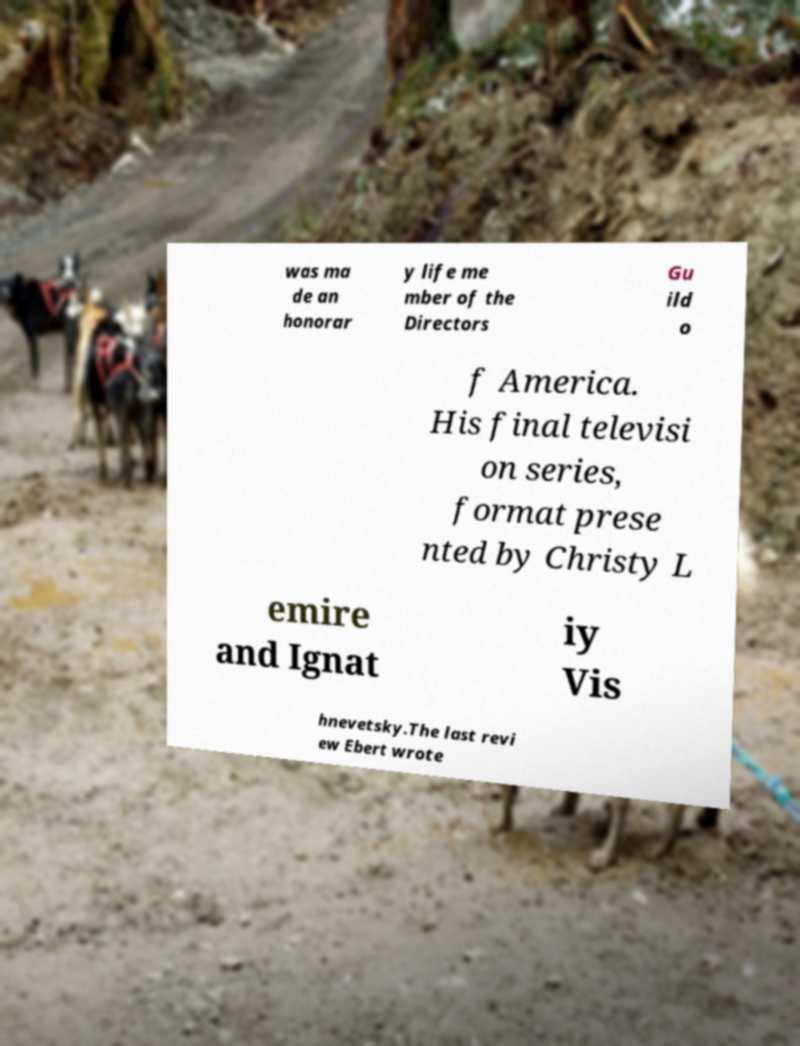There's text embedded in this image that I need extracted. Can you transcribe it verbatim? was ma de an honorar y life me mber of the Directors Gu ild o f America. His final televisi on series, format prese nted by Christy L emire and Ignat iy Vis hnevetsky.The last revi ew Ebert wrote 